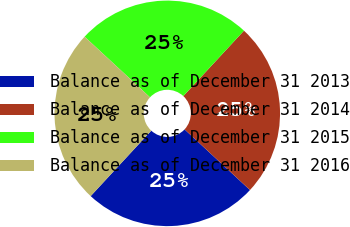Convert chart. <chart><loc_0><loc_0><loc_500><loc_500><pie_chart><fcel>Balance as of December 31 2013<fcel>Balance as of December 31 2014<fcel>Balance as of December 31 2015<fcel>Balance as of December 31 2016<nl><fcel>24.99%<fcel>25.0%<fcel>25.0%<fcel>25.01%<nl></chart> 